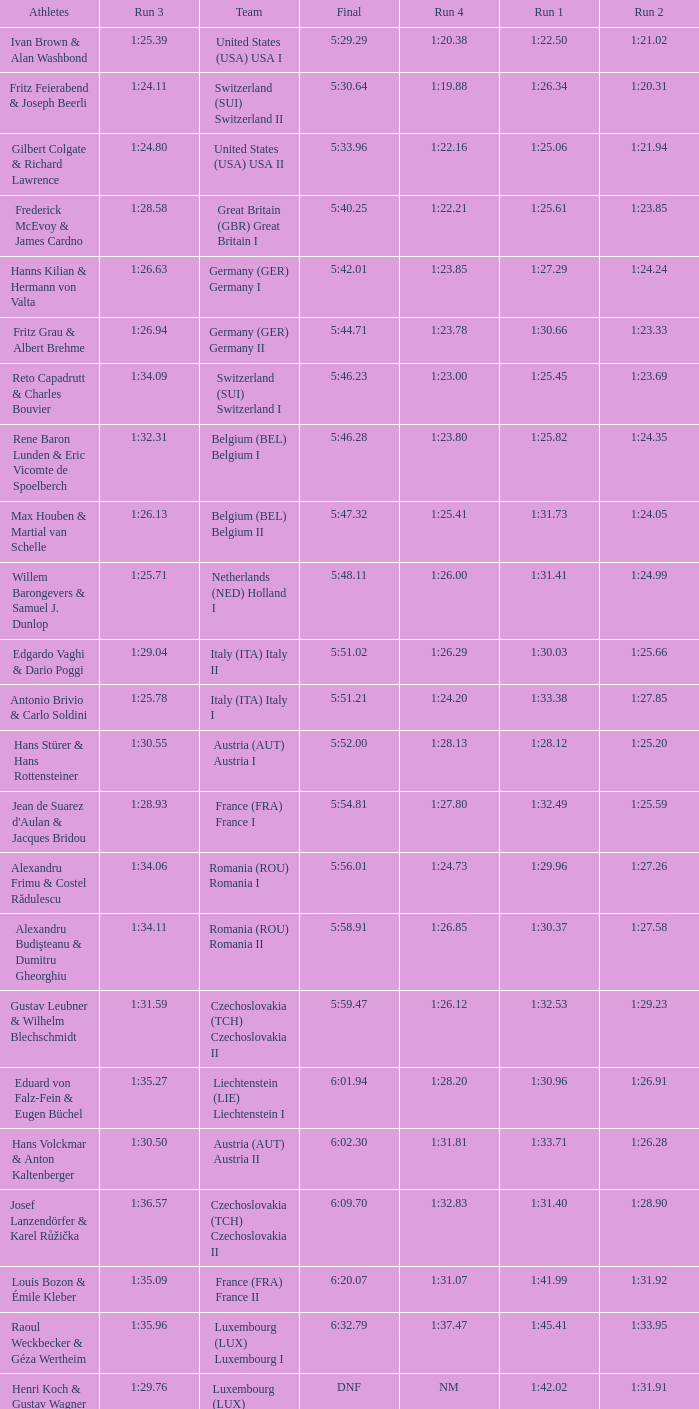Which Final has a Run 2 of 1:27.58? 5:58.91. 